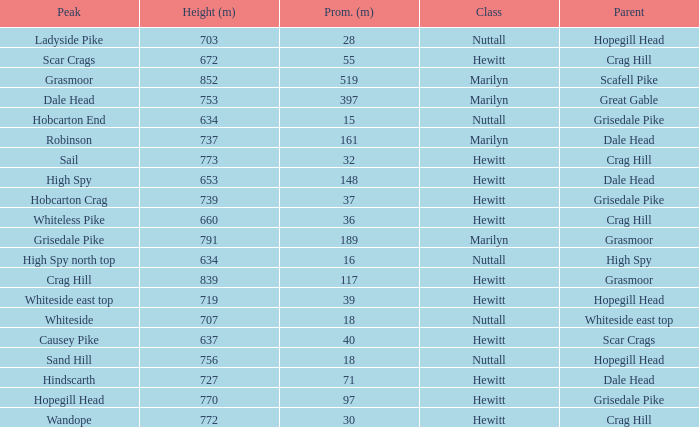What is the lowest height for Parent grasmoor when it has a Prom larger than 117? 791.0. 